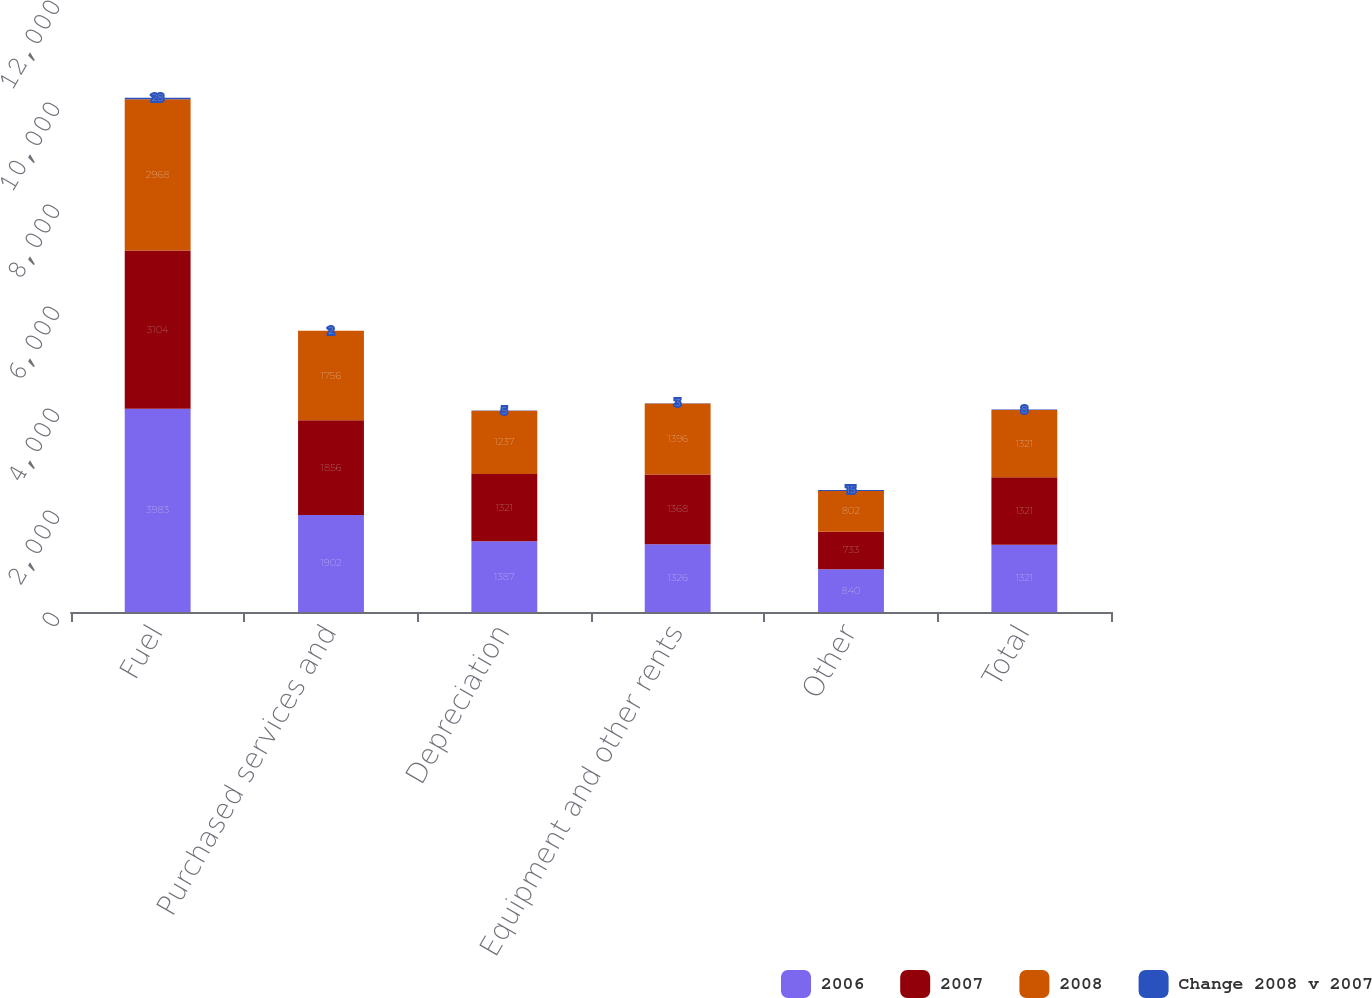Convert chart to OTSL. <chart><loc_0><loc_0><loc_500><loc_500><stacked_bar_chart><ecel><fcel>Fuel<fcel>Purchased services and<fcel>Depreciation<fcel>Equipment and other rents<fcel>Other<fcel>Total<nl><fcel>2006<fcel>3983<fcel>1902<fcel>1387<fcel>1326<fcel>840<fcel>1321<nl><fcel>2007<fcel>3104<fcel>1856<fcel>1321<fcel>1368<fcel>733<fcel>1321<nl><fcel>2008<fcel>2968<fcel>1756<fcel>1237<fcel>1396<fcel>802<fcel>1321<nl><fcel>Change 2008 v 2007<fcel>28<fcel>2<fcel>5<fcel>3<fcel>15<fcel>8<nl></chart> 